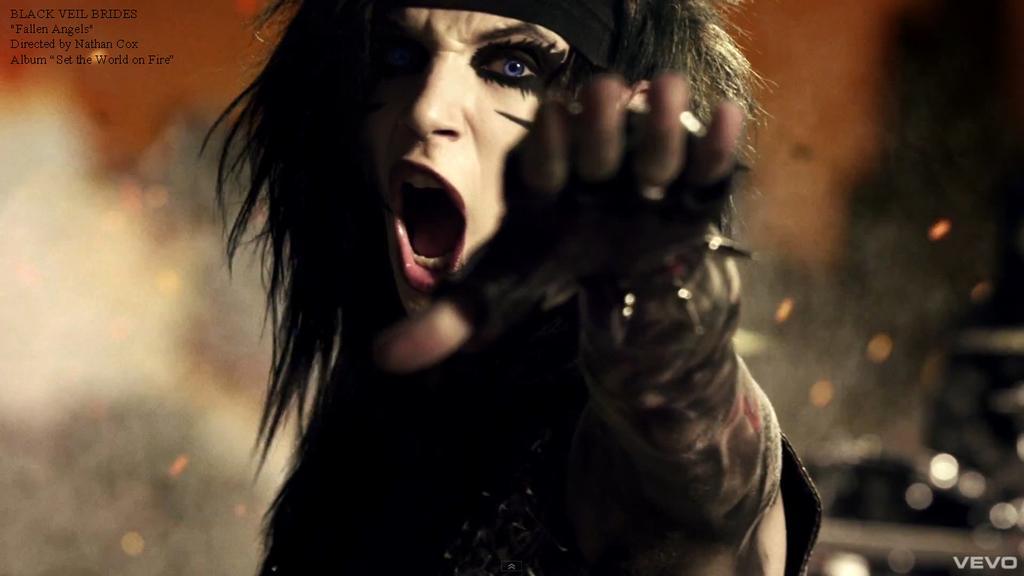Please provide a concise description of this image. In this picture we can see a person and behind the person there is the blurred background. On the image there are watermarks. 